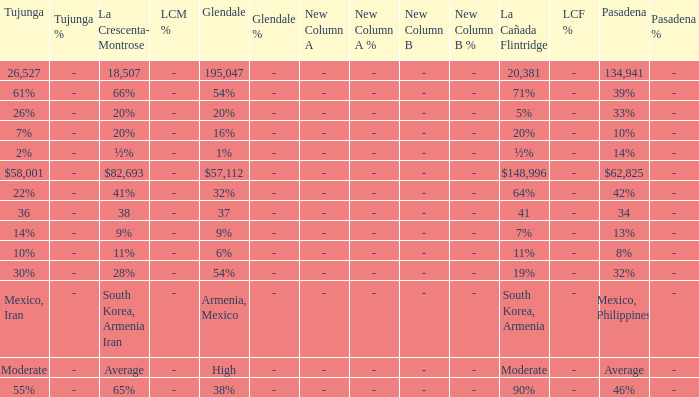What is the percentage of Glendale when Pasadena is 14%? 1%. 